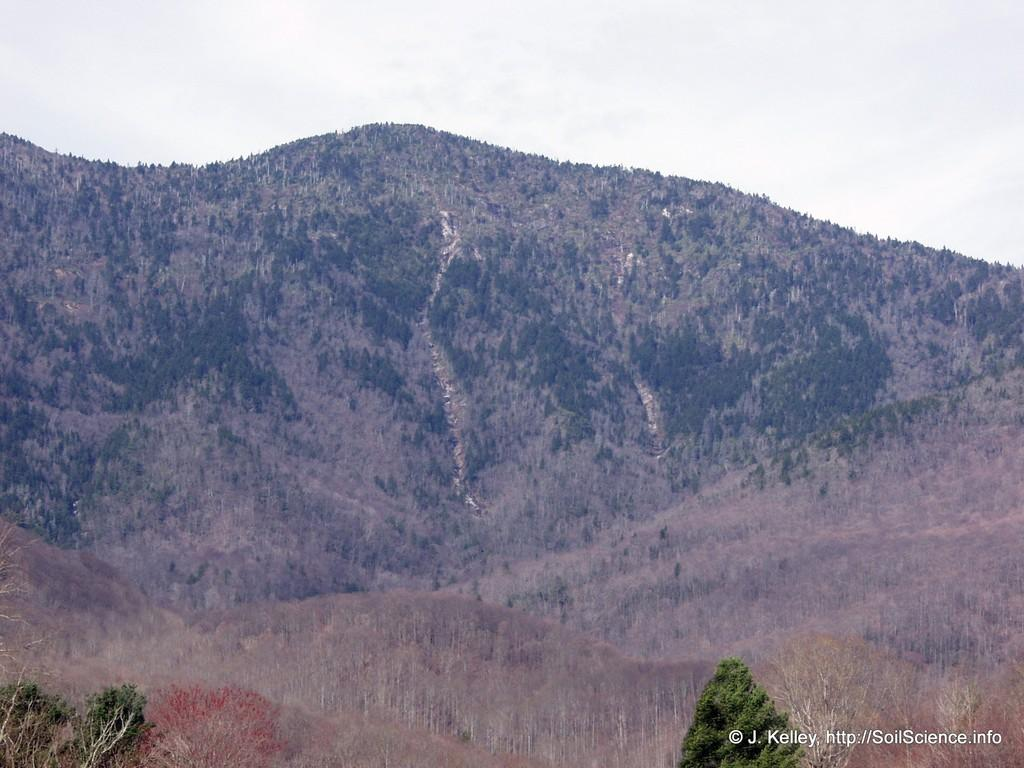What type of natural features can be seen in the image? There are trees and mountains in the image. What is visible in the background of the image? The sky is visible in the background of the image. What type of brass instrument is being played by the dog in the image? There is no dog or brass instrument present in the image. What type of poison is being used to kill the trees in the image? There is no poison or indication of harm to the trees in the image. 